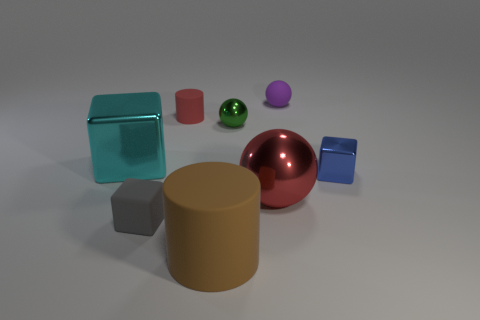What is the size of the metal object that is the same color as the small cylinder?
Your answer should be very brief. Large. What shape is the object that is the same color as the big metallic ball?
Your answer should be very brief. Cylinder. What number of other purple rubber things are the same shape as the small purple object?
Offer a terse response. 0. What number of cyan metal objects are the same size as the red cylinder?
Provide a succinct answer. 0. There is a big object that is the same shape as the tiny purple thing; what is its material?
Keep it short and to the point. Metal. There is a metal object in front of the tiny metallic block; what color is it?
Offer a terse response. Red. Are there more small green shiny objects that are in front of the matte ball than brown blocks?
Ensure brevity in your answer.  Yes. What color is the big metal sphere?
Your response must be concise. Red. What is the shape of the large metallic object that is behind the object right of the matte thing to the right of the small green metallic object?
Your answer should be very brief. Cube. The block that is behind the red shiny sphere and to the left of the big red object is made of what material?
Your response must be concise. Metal. 